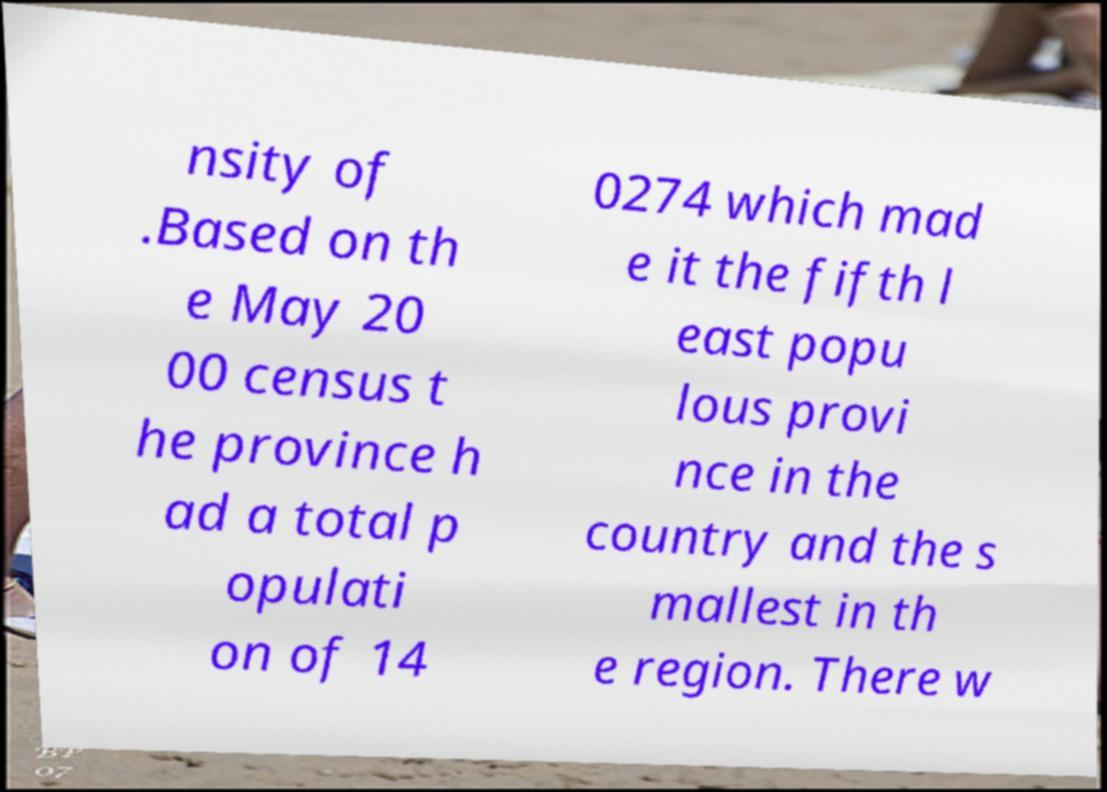What messages or text are displayed in this image? I need them in a readable, typed format. nsity of .Based on th e May 20 00 census t he province h ad a total p opulati on of 14 0274 which mad e it the fifth l east popu lous provi nce in the country and the s mallest in th e region. There w 